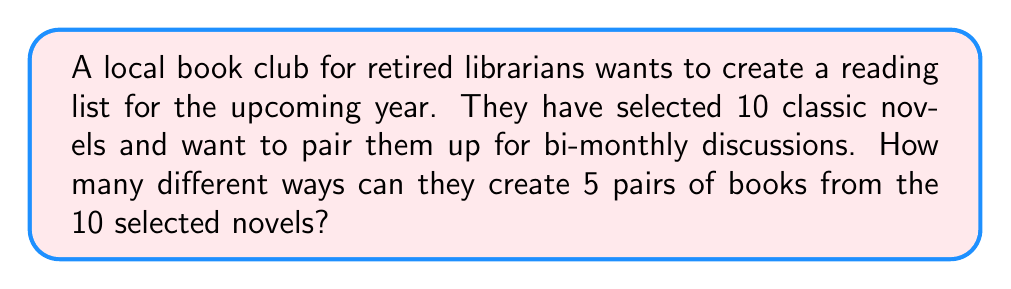Could you help me with this problem? Let's approach this step-by-step:

1) First, we need to understand that this is a pairing problem. We're essentially choosing 2 books at a time from the 10 books, and we're doing this 5 times until all books are paired.

2) To solve this, we can use the concept of double factorial. The double factorial of an odd number $n$, denoted as $n!!$, is the product of all odd numbers from 1 to $n$.

3) In this case, we're interested in $9!!$ because:
   - For the first pair, we have 10 choices for the first book and 9 for the second.
   - For the second pair, we have 8 choices for the first book and 7 for the second.
   - This continues until we have 2 choices for the first book of the last pair and 1 for the second.

4) The formula for the number of ways to pair $2n$ objects is:

   $$(2n-1)!! = (2n-1) \times (2n-3) \times (2n-5) \times ... \times 3 \times 1$$

5) In our case, $n = 5$ (5 pairs from 10 books), so we need to calculate $9!!$:

   $$9!! = 9 \times 7 \times 5 \times 3 \times 1 = 945$$

6) Therefore, there are 945 different ways to create 5 pairs of books from the 10 selected novels.
Answer: 945 